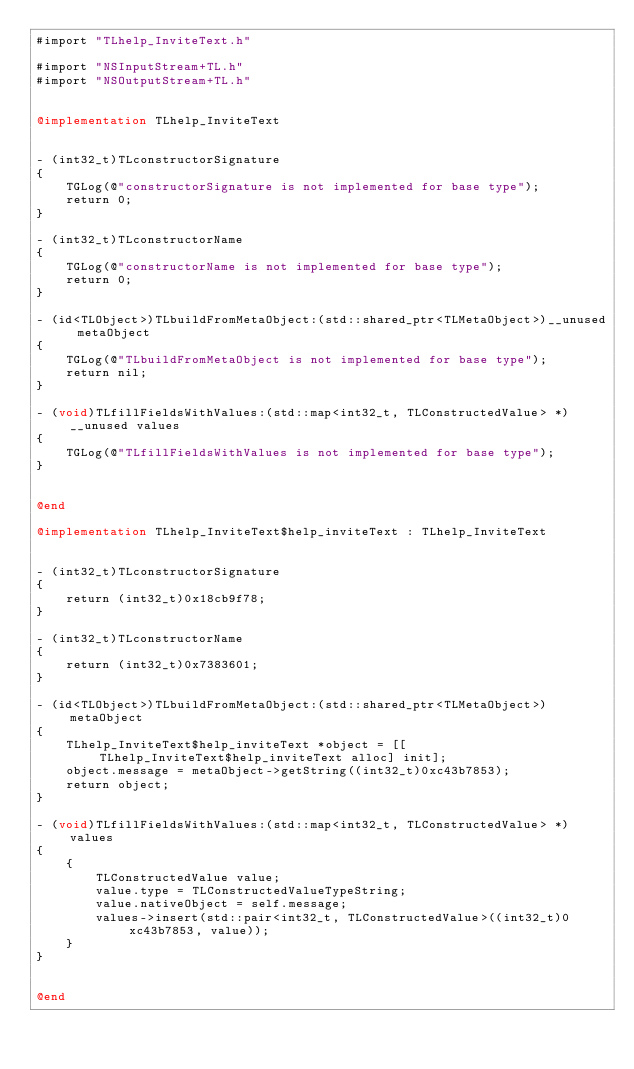<code> <loc_0><loc_0><loc_500><loc_500><_ObjectiveC_>#import "TLhelp_InviteText.h"

#import "NSInputStream+TL.h"
#import "NSOutputStream+TL.h"


@implementation TLhelp_InviteText


- (int32_t)TLconstructorSignature
{
    TGLog(@"constructorSignature is not implemented for base type");
    return 0;
}

- (int32_t)TLconstructorName
{
    TGLog(@"constructorName is not implemented for base type");
    return 0;
}

- (id<TLObject>)TLbuildFromMetaObject:(std::shared_ptr<TLMetaObject>)__unused metaObject
{
    TGLog(@"TLbuildFromMetaObject is not implemented for base type");
    return nil;
}

- (void)TLfillFieldsWithValues:(std::map<int32_t, TLConstructedValue> *)__unused values
{
    TGLog(@"TLfillFieldsWithValues is not implemented for base type");
}


@end

@implementation TLhelp_InviteText$help_inviteText : TLhelp_InviteText


- (int32_t)TLconstructorSignature
{
    return (int32_t)0x18cb9f78;
}

- (int32_t)TLconstructorName
{
    return (int32_t)0x7383601;
}

- (id<TLObject>)TLbuildFromMetaObject:(std::shared_ptr<TLMetaObject>)metaObject
{
    TLhelp_InviteText$help_inviteText *object = [[TLhelp_InviteText$help_inviteText alloc] init];
    object.message = metaObject->getString((int32_t)0xc43b7853);
    return object;
}

- (void)TLfillFieldsWithValues:(std::map<int32_t, TLConstructedValue> *)values
{
    {
        TLConstructedValue value;
        value.type = TLConstructedValueTypeString;
        value.nativeObject = self.message;
        values->insert(std::pair<int32_t, TLConstructedValue>((int32_t)0xc43b7853, value));
    }
}


@end

</code> 